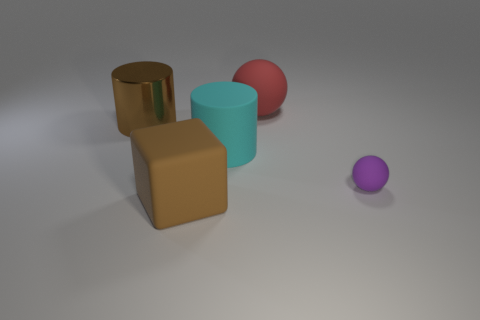Add 1 big rubber blocks. How many objects exist? 6 Subtract all green cylinders. Subtract all brown blocks. How many cylinders are left? 2 Subtract all blocks. How many objects are left? 4 Add 4 large red spheres. How many large red spheres are left? 5 Add 2 brown matte objects. How many brown matte objects exist? 3 Subtract 0 blue cylinders. How many objects are left? 5 Subtract all blocks. Subtract all shiny cylinders. How many objects are left? 3 